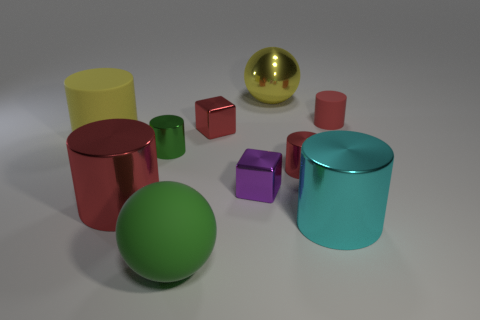What is the material of the red cylinder that is the same size as the cyan metallic cylinder?
Offer a very short reply. Metal. There is a big matte ball; are there any green metallic things on the left side of it?
Your response must be concise. Yes. Is the number of tiny cubes right of the big cyan object the same as the number of balls?
Give a very brief answer. No. There is another matte object that is the same size as the green rubber object; what is its shape?
Your answer should be compact. Cylinder. What material is the large yellow cylinder?
Your answer should be very brief. Rubber. What color is the matte thing that is both behind the large green object and on the right side of the green cylinder?
Keep it short and to the point. Red. Is the number of big metallic things behind the big red thing the same as the number of red metallic objects that are behind the yellow matte cylinder?
Offer a very short reply. Yes. What color is the big ball that is the same material as the cyan thing?
Your response must be concise. Yellow. There is a big rubber ball; is its color the same as the metal thing left of the green metal cylinder?
Provide a succinct answer. No. There is a ball on the left side of the big thing behind the small red rubber cylinder; are there any big matte things on the left side of it?
Offer a very short reply. Yes. 